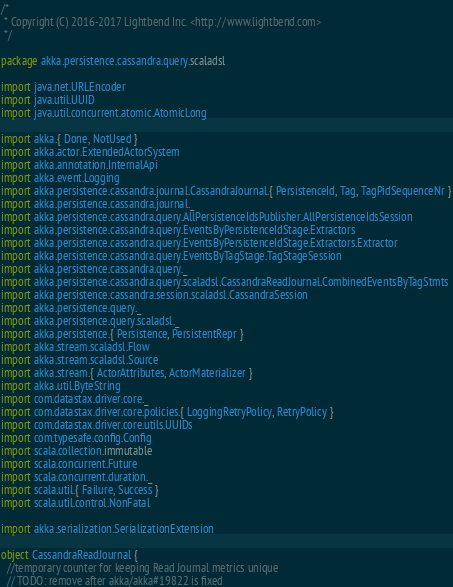<code> <loc_0><loc_0><loc_500><loc_500><_Scala_>/*
 * Copyright (C) 2016-2017 Lightbend Inc. <http://www.lightbend.com>
 */

package akka.persistence.cassandra.query.scaladsl

import java.net.URLEncoder
import java.util.UUID
import java.util.concurrent.atomic.AtomicLong

import akka.{ Done, NotUsed }
import akka.actor.ExtendedActorSystem
import akka.annotation.InternalApi
import akka.event.Logging
import akka.persistence.cassandra.journal.CassandraJournal.{ PersistenceId, Tag, TagPidSequenceNr }
import akka.persistence.cassandra.journal._
import akka.persistence.cassandra.query.AllPersistenceIdsPublisher.AllPersistenceIdsSession
import akka.persistence.cassandra.query.EventsByPersistenceIdStage.Extractors
import akka.persistence.cassandra.query.EventsByPersistenceIdStage.Extractors.Extractor
import akka.persistence.cassandra.query.EventsByTagStage.TagStageSession
import akka.persistence.cassandra.query._
import akka.persistence.cassandra.query.scaladsl.CassandraReadJournal.CombinedEventsByTagStmts
import akka.persistence.cassandra.session.scaladsl.CassandraSession
import akka.persistence.query._
import akka.persistence.query.scaladsl._
import akka.persistence.{ Persistence, PersistentRepr }
import akka.stream.scaladsl.Flow
import akka.stream.scaladsl.Source
import akka.stream.{ ActorAttributes, ActorMaterializer }
import akka.util.ByteString
import com.datastax.driver.core._
import com.datastax.driver.core.policies.{ LoggingRetryPolicy, RetryPolicy }
import com.datastax.driver.core.utils.UUIDs
import com.typesafe.config.Config
import scala.collection.immutable
import scala.concurrent.Future
import scala.concurrent.duration._
import scala.util.{ Failure, Success }
import scala.util.control.NonFatal

import akka.serialization.SerializationExtension

object CassandraReadJournal {
  //temporary counter for keeping Read Journal metrics unique
  // TODO: remove after akka/akka#19822 is fixed</code> 